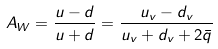Convert formula to latex. <formula><loc_0><loc_0><loc_500><loc_500>A _ { W } = \frac { u - d } { u + d } = \frac { u _ { v } - d _ { v } } { u _ { v } + d _ { v } + 2 \bar { q } }</formula> 